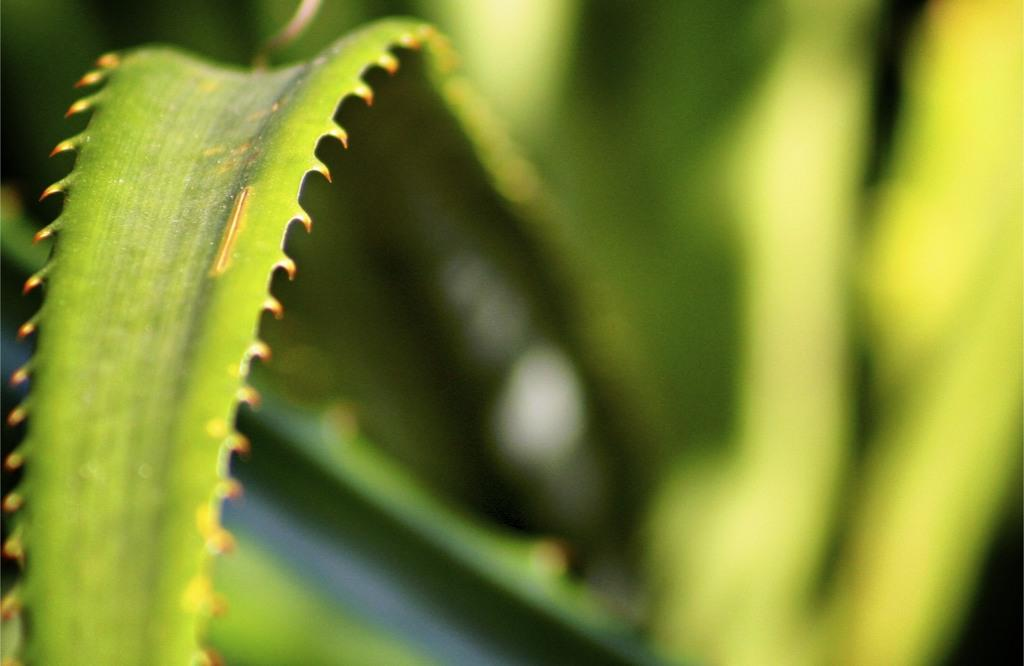What is present in the picture? There is a leaf in the picture. Can you describe the leaf's appearance? The leaf has sharp edges. What color is the leaf? The leaf is green in color. How does the leaf express anger in the image? The leaf does not express anger in the image, as it is an inanimate object and cannot display emotions. 